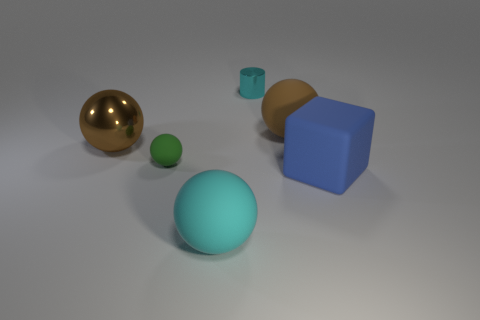Do the big rubber sphere that is on the left side of the tiny shiny cylinder and the tiny metal cylinder have the same color?
Keep it short and to the point. Yes. What number of matte objects are the same color as the tiny metallic cylinder?
Provide a succinct answer. 1. There is a big ball on the right side of the big cyan object; what is its material?
Your response must be concise. Rubber. Are there any other metal objects of the same size as the brown metallic thing?
Provide a succinct answer. No. There is a green matte thing; is it the same shape as the matte thing in front of the matte cube?
Provide a short and direct response. Yes. There is a rubber sphere on the right side of the metal cylinder; is its size the same as the cyan thing behind the brown rubber ball?
Offer a terse response. No. How many other objects are there of the same shape as the brown matte object?
Give a very brief answer. 3. What is the material of the brown ball that is on the left side of the ball that is behind the metallic sphere?
Give a very brief answer. Metal. How many rubber objects are either cylinders or tiny red balls?
Keep it short and to the point. 0. There is a big rubber ball that is behind the large block; are there any balls in front of it?
Offer a terse response. Yes. 